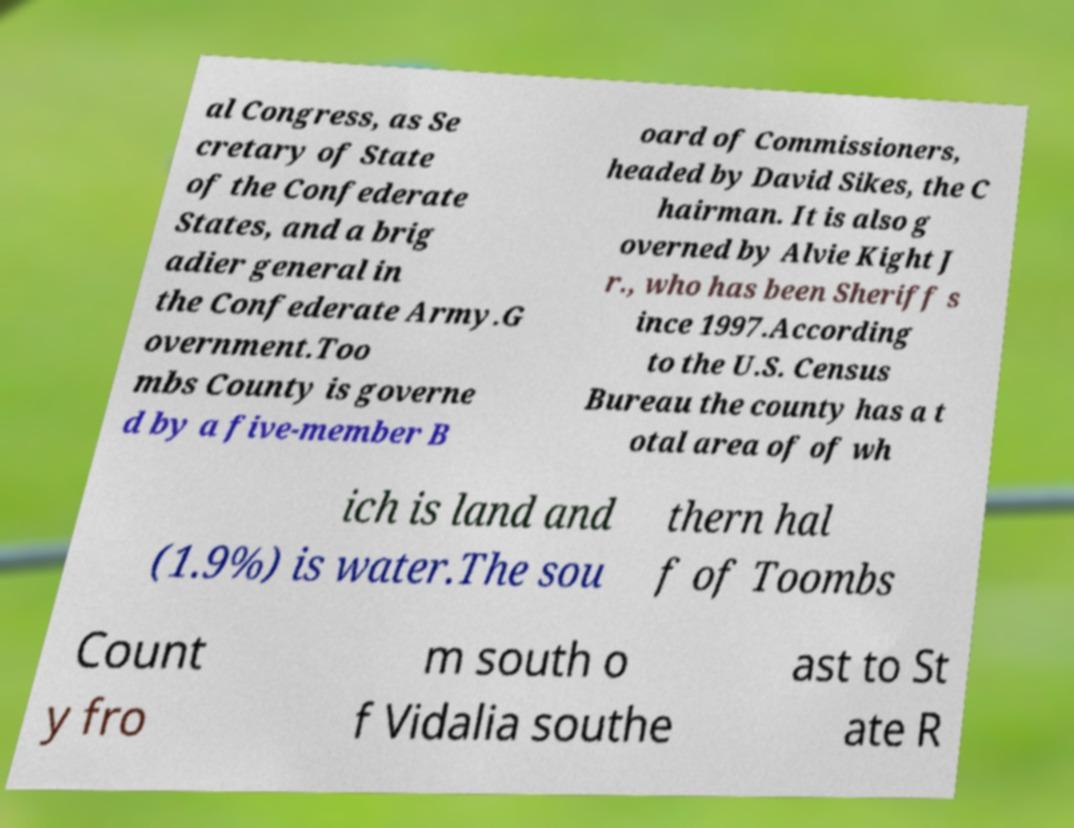Can you accurately transcribe the text from the provided image for me? al Congress, as Se cretary of State of the Confederate States, and a brig adier general in the Confederate Army.G overnment.Too mbs County is governe d by a five-member B oard of Commissioners, headed by David Sikes, the C hairman. It is also g overned by Alvie Kight J r., who has been Sheriff s ince 1997.According to the U.S. Census Bureau the county has a t otal area of of wh ich is land and (1.9%) is water.The sou thern hal f of Toombs Count y fro m south o f Vidalia southe ast to St ate R 